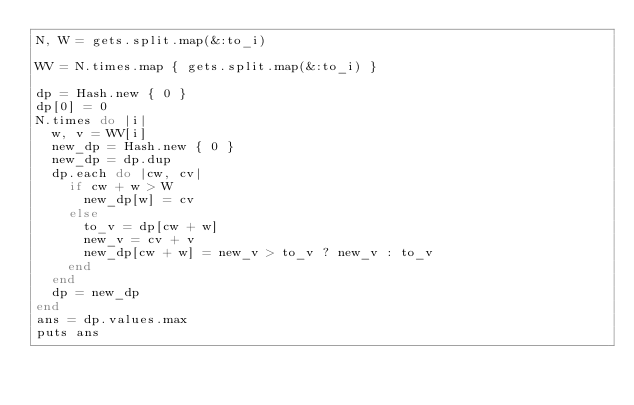Convert code to text. <code><loc_0><loc_0><loc_500><loc_500><_Ruby_>N, W = gets.split.map(&:to_i)

WV = N.times.map { gets.split.map(&:to_i) }

dp = Hash.new { 0 }
dp[0] = 0
N.times do |i|
  w, v = WV[i]
  new_dp = Hash.new { 0 }
  new_dp = dp.dup
  dp.each do |cw, cv|
    if cw + w > W
      new_dp[w] = cv
    else
      to_v = dp[cw + w]
      new_v = cv + v
      new_dp[cw + w] = new_v > to_v ? new_v : to_v
    end
  end
  dp = new_dp
end
ans = dp.values.max
puts ans</code> 